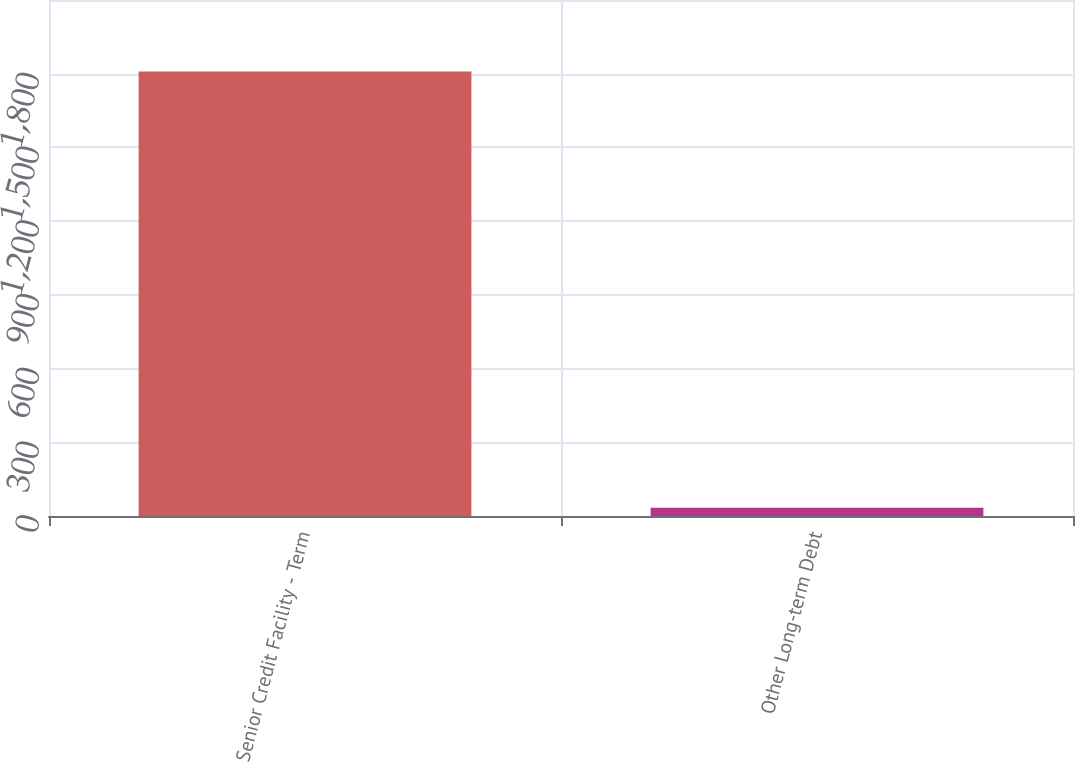<chart> <loc_0><loc_0><loc_500><loc_500><bar_chart><fcel>Senior Credit Facility - Term<fcel>Other Long-term Debt<nl><fcel>1809<fcel>33.8<nl></chart> 